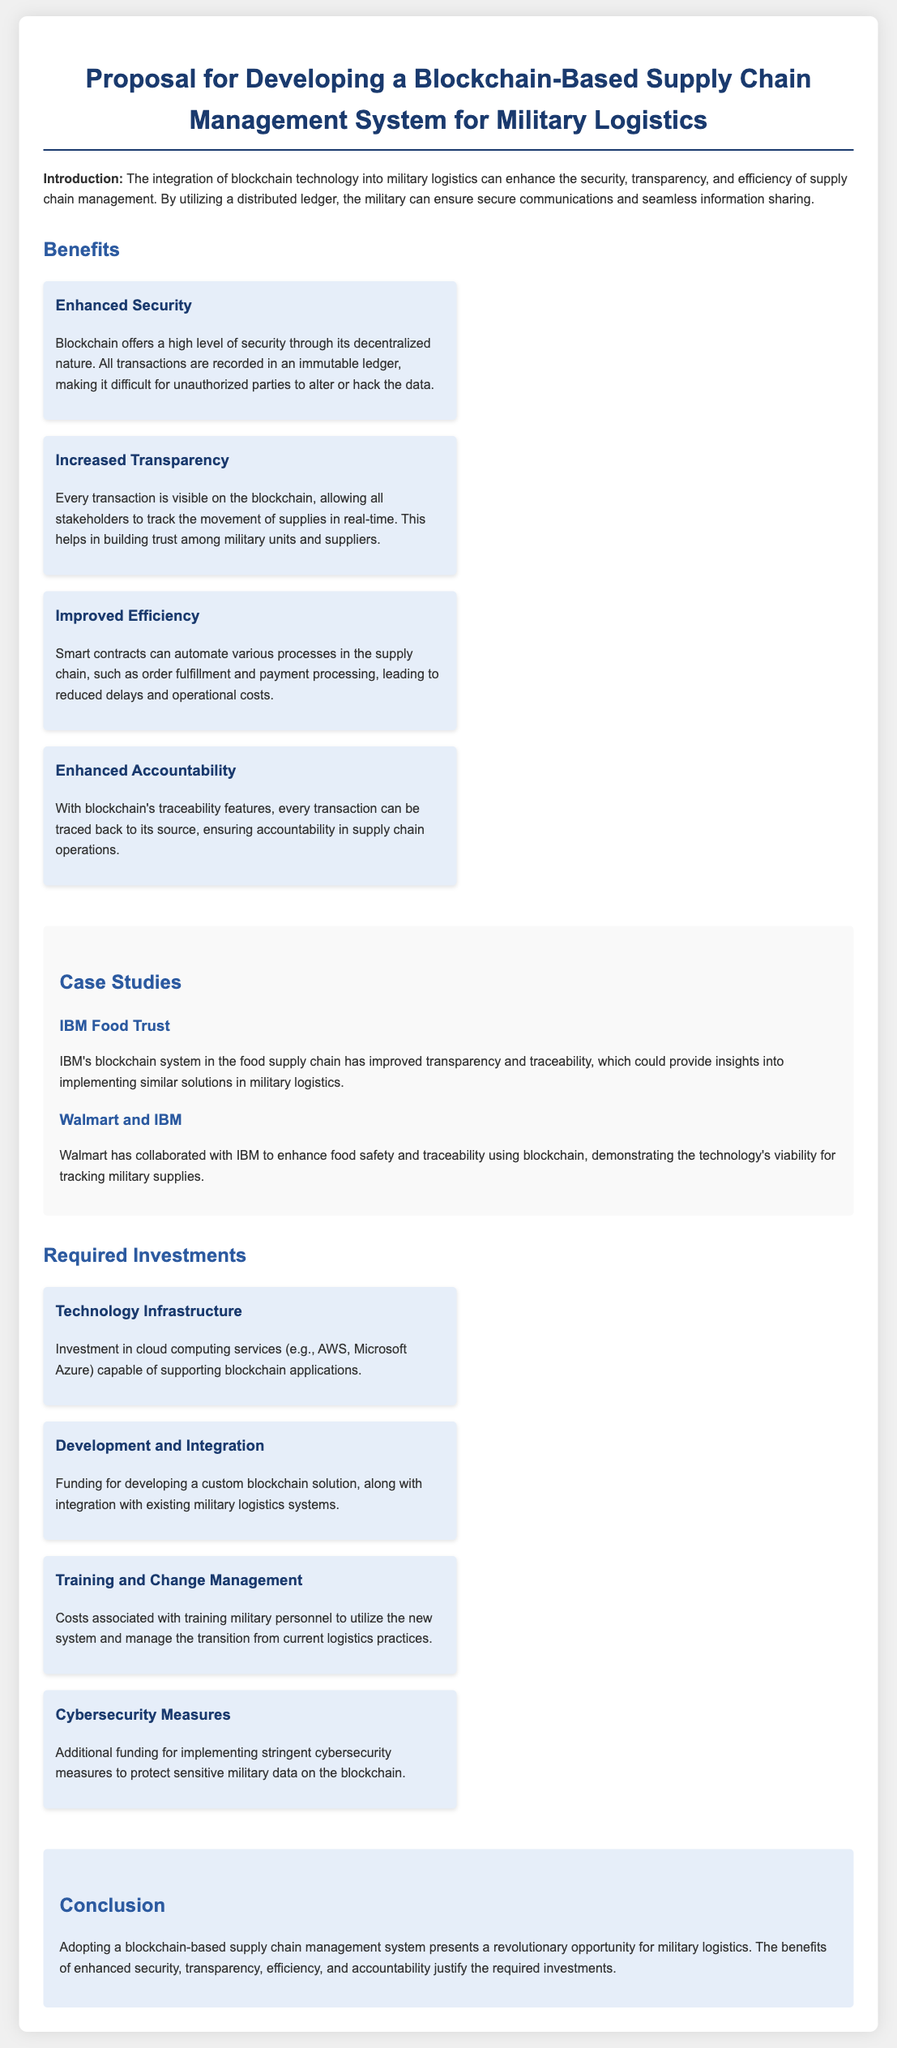What are the benefits of blockchain in military logistics? The document lists benefits including Enhanced Security, Increased Transparency, Improved Efficiency, and Enhanced Accountability.
Answer: Enhanced Security, Increased Transparency, Improved Efficiency, Enhanced Accountability What is one case study mentioned? The document references IBM Food Trust and Walmart and IBM as case studies demonstrating blockchain implementation.
Answer: IBM Food Trust What type of investment is required for technology infrastructure? Investment in cloud computing services that can support blockchain applications is mentioned under the required investments.
Answer: Cloud computing services What does the proposal aim to enhance? The proposal aims to enhance security, transparency, and efficiency in supply chain management.
Answer: Security, transparency, efficiency How can smart contracts improve military logistics? Smart contracts can automate various processes, leading to reduced delays and operational costs.
Answer: Automate processes What additional funding is needed for protecting military data? The document specifies that additional funding is necessary for implementing stringent cybersecurity measures.
Answer: Cybersecurity measures What is the main conclusion of the proposal? The conclusion emphasizes that the benefits justify the required investments in a blockchain-based supply chain management system.
Answer: Benefits justify investments What type of document is this? The document is a proposal for developing a blockchain-based supply chain management system.
Answer: Proposal How many benefit categories are listed? There are four benefit categories listed in the document.
Answer: Four 